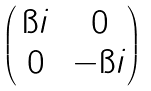<formula> <loc_0><loc_0><loc_500><loc_500>\begin{pmatrix} \, \i i \, & 0 \\ 0 & - \i i \end{pmatrix}</formula> 